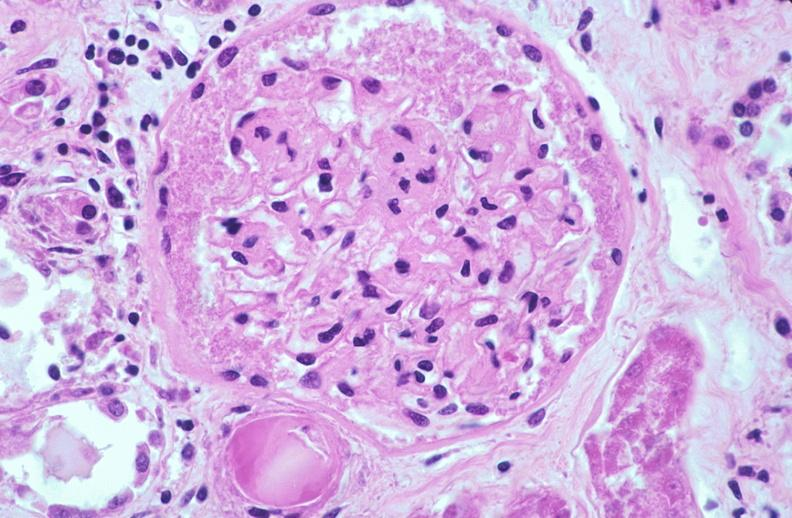what does this image show?
Answer the question using a single word or phrase. Kidney glomerulus 